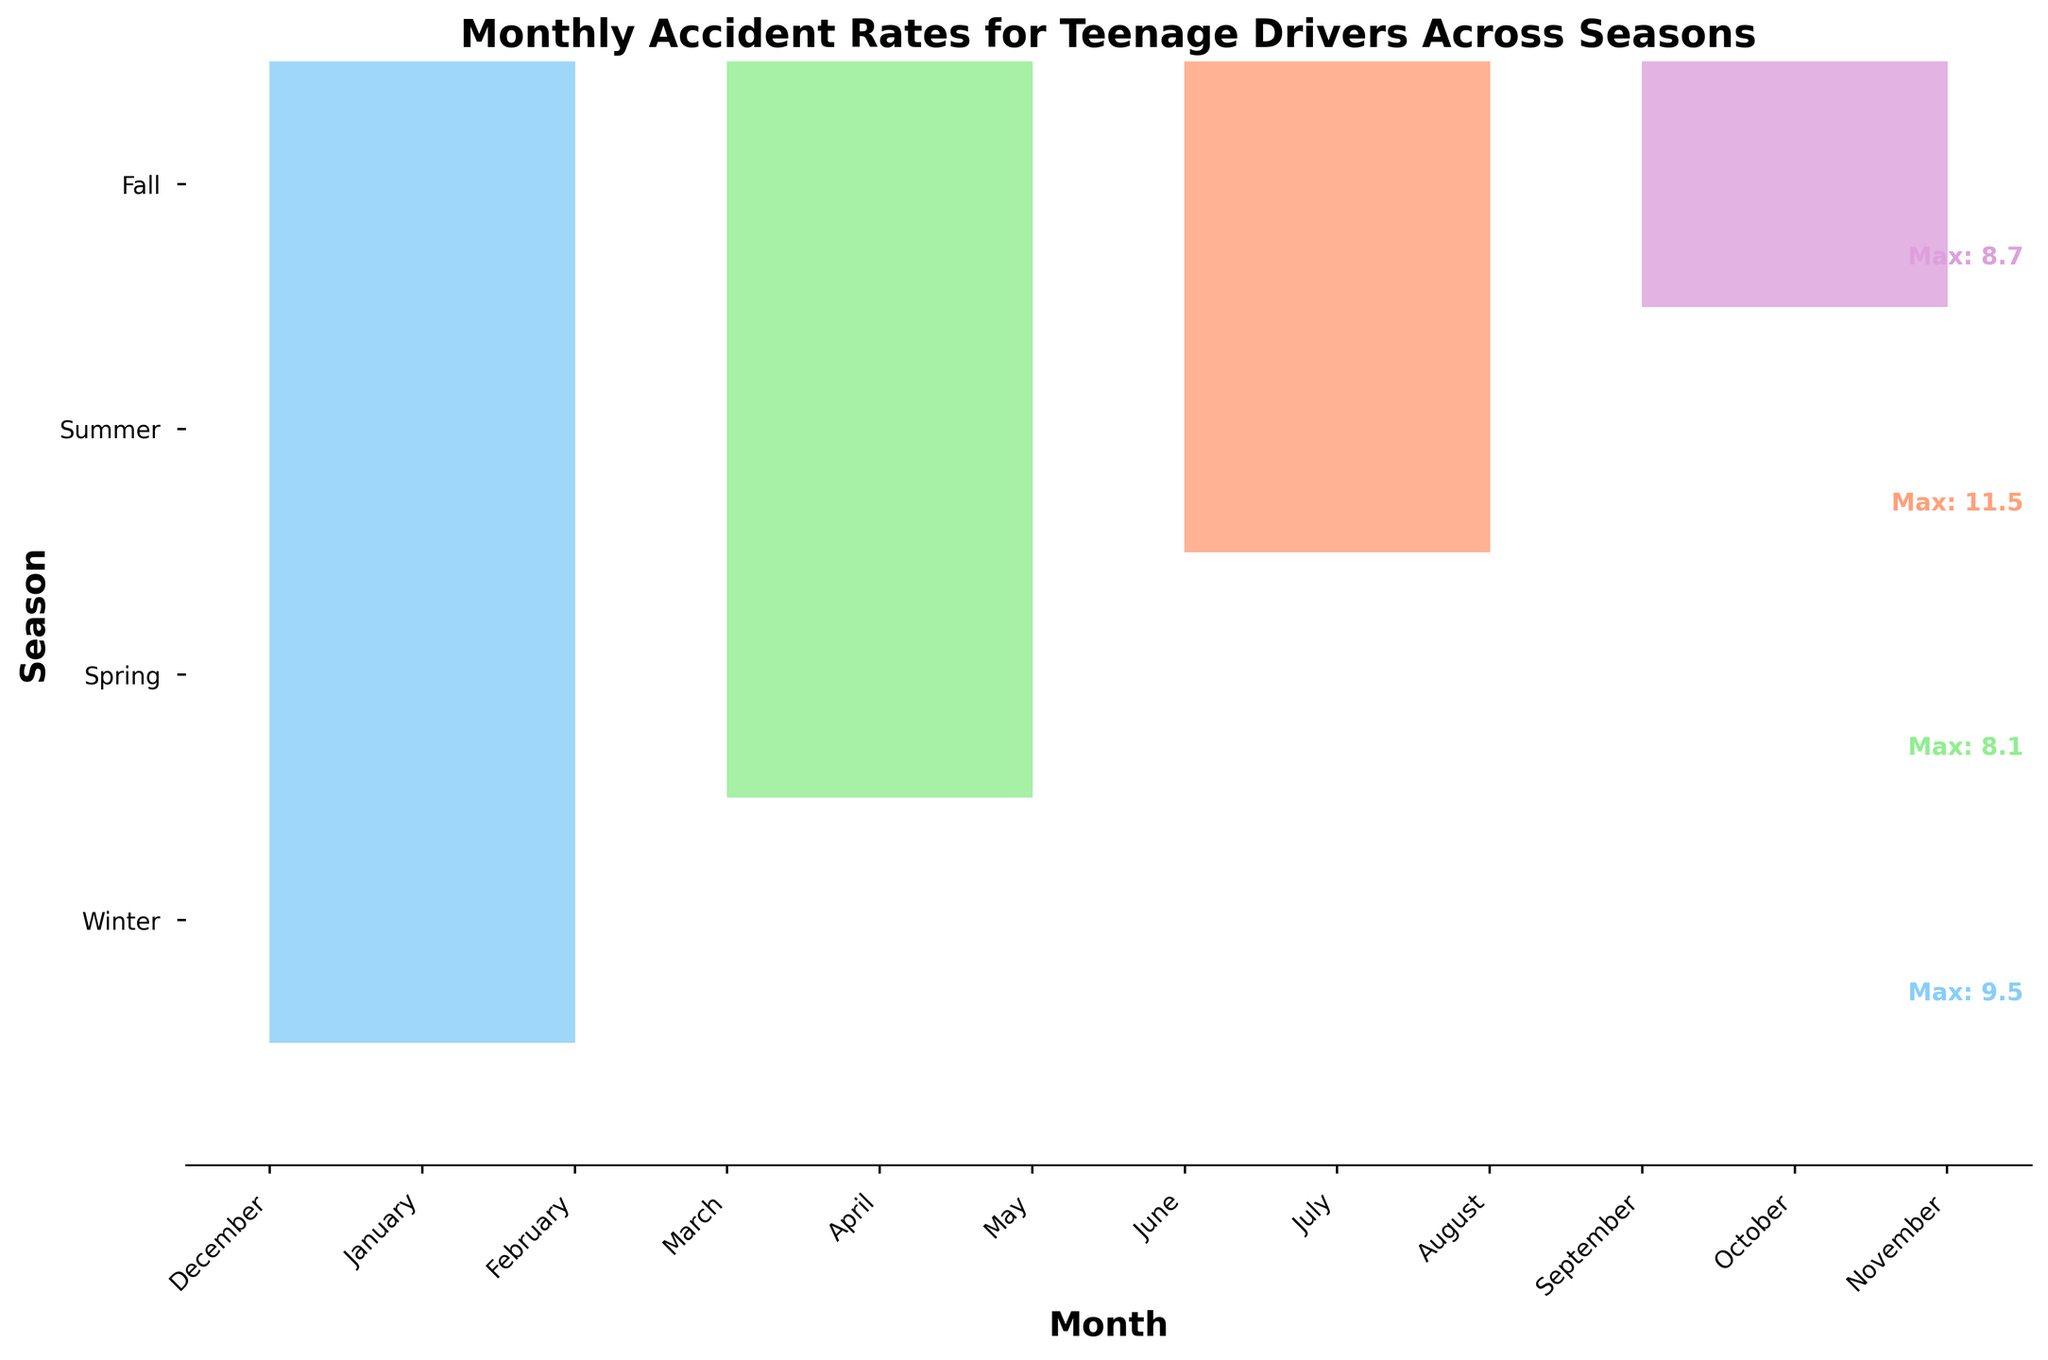What is the title of the figure? The title of the figure is usually located at the top and summarizes what the figure is about. By looking at the top of the figure, "Monthly Accident Rates for Teenage Drivers Across Seasons" is stated.
Answer: Monthly Accident Rates for Teenage Drivers Across Seasons Which season has the highest monthly accident rate? The season with the highest monthly accident rate can be identified by comparing the peaks of each season's ridge in the plot. The plot shows that the summer ridge has the highest peak.
Answer: Summer What is the accident rate for January? To find the accident rate for January, locate the January point on the Winter ridge. The plot indicates a rate of 9.5 for January.
Answer: 9.5 Which month in Fall shows the lowest accident rate? Observe the values for each month within the Fall segment. October has the lowest rate, marked at 7.6.
Answer: October How does the accident rate in July compare to June? Locate July and June on the Summer ridge and compare their heights. July has an accident rate of 11.5, while June has 10.2. July's rate is higher than June's.
Answer: July is higher Is the December accident rate higher than November? Compare the accident rate for December and November. December is on the Winter ridge with a rate of 8.2, and November on the Fall ridge has an 8.3 rate. November is slightly higher.
Answer: No What's the seasonal average of the accident rates in Spring? Calculate the average of the rates for March, April, and May. (6.9 + 7.3 + 8.1) / 3 = 22.3 / 3 ≈ 7.4
Answer: 7.4 Which season has the most consistent accident rates? Consistency can be determined by the range (difference between max and min) of accident rates within each season. Fall ranges from 7.6 to 8.7, yielding 1.1, the smallest range among the seasons.
Answer: Fall What is the range of accident rates in Winter? Subtract the lowest value in Winter (February, 7.8) from the highest (January, 9.5). 9.5 - 7.8 = 1.7
Answer: 1.7 What is the highest accident rate displayed for any month? Identify the highest peak across all ridges. July within Summer has the highest rate at 11.5.
Answer: 11.5 